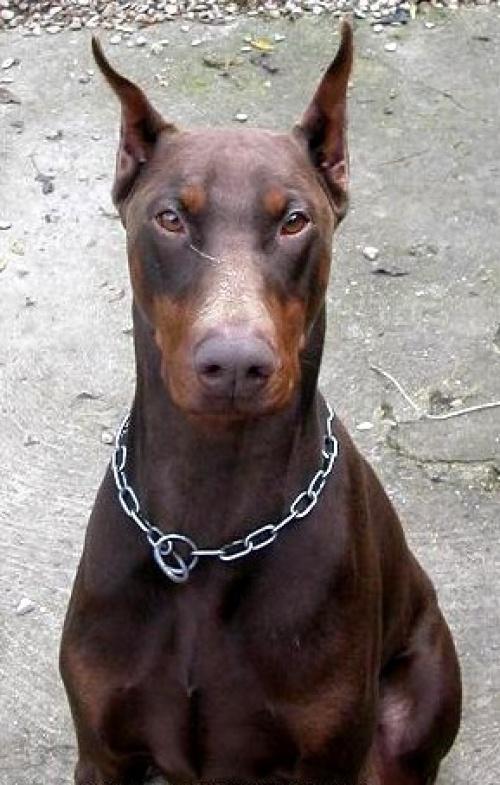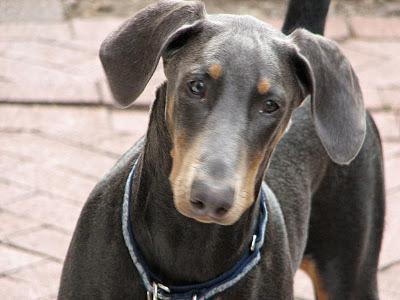The first image is the image on the left, the second image is the image on the right. Assess this claim about the two images: "A dog facing left and is near a man.". Correct or not? Answer yes or no. No. The first image is the image on the left, the second image is the image on the right. Given the left and right images, does the statement "One image contains one pointy-eared doberman wearing a collar that has pale beige fur with mottled tan spots." hold true? Answer yes or no. No. 